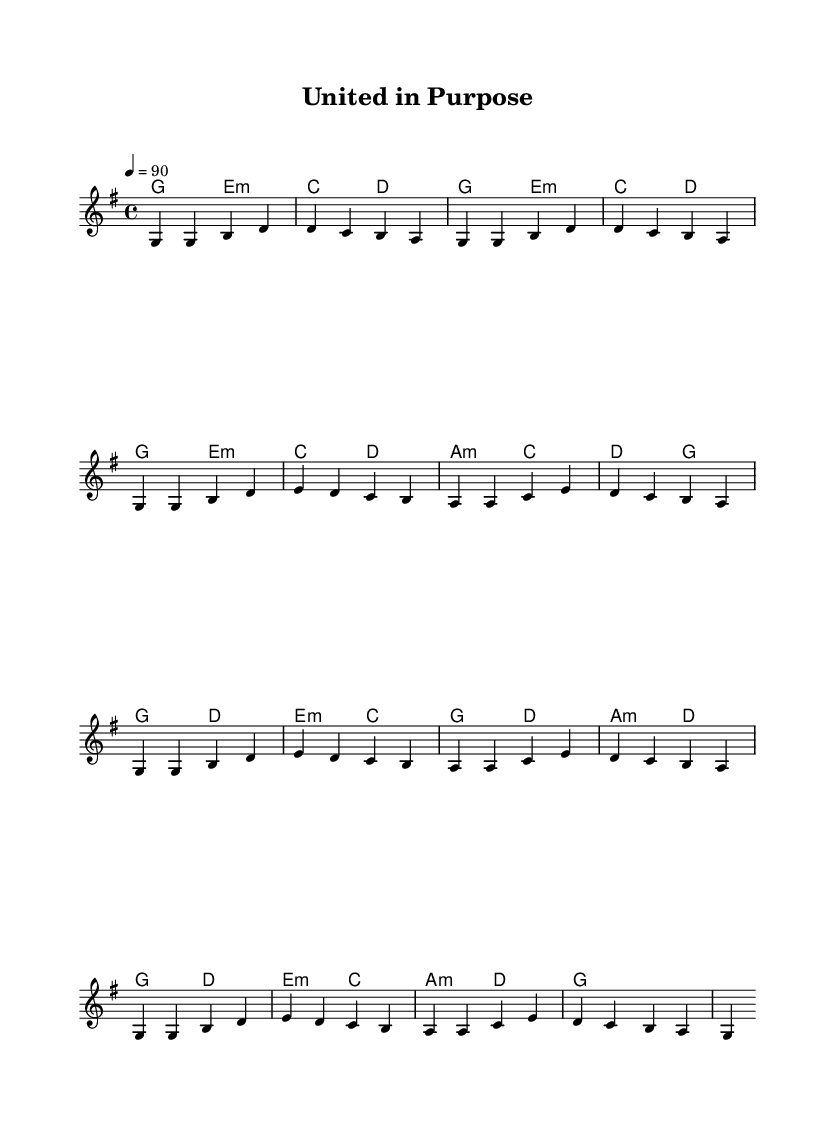What is the key signature of this music? The key signature is G major, which has one sharp (F#). This can be determined by looking at the key signature indicated at the beginning of the score.
Answer: G major What is the time signature of this piece? The time signature is 4/4, which is shown at the start of the score. This means there are four beats in each measure, and the quarter note gets one beat.
Answer: 4/4 What is the tempo marking given for this music? The tempo marking is 90 beats per minute, indicated as "4 = 90" at the top of the score. This directs how fast the piece should be played.
Answer: 90 How many measures are in the verse section? The verse section contains eight measures. By counting the bars shown in the melody section for the verse, we find there are eight individual measures.
Answer: Eight What are the main themes expressed in the lyrics of this song? The main themes revolve around unity, faith, and purpose, as evidenced by phrases such as "together we stand" and "united in purpose." Analyzing the lyrics shows a focus on coming together in faith, which is central to Contemporary Christian worship.
Answer: Unity, faith, purpose How many different chords are played in the chorus section? There are four different chords used in the chorus section (G, D, E minor, and C). Counting the distinct chord names in the harmonies part during the chorus confirms this.
Answer: Four 